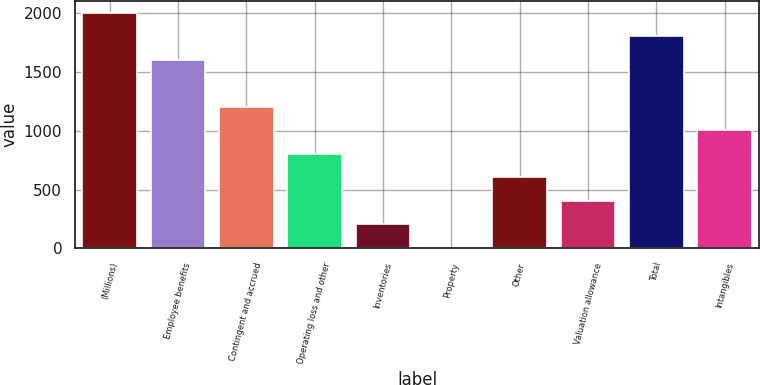<chart> <loc_0><loc_0><loc_500><loc_500><bar_chart><fcel>(Millions)<fcel>Employee benefits<fcel>Contingent and accrued<fcel>Operating loss and other<fcel>Inventories<fcel>Property<fcel>Other<fcel>Valuation allowance<fcel>Total<fcel>Intangibles<nl><fcel>2007<fcel>1606.2<fcel>1205.4<fcel>804.6<fcel>203.4<fcel>3<fcel>604.2<fcel>403.8<fcel>1806.6<fcel>1005<nl></chart> 